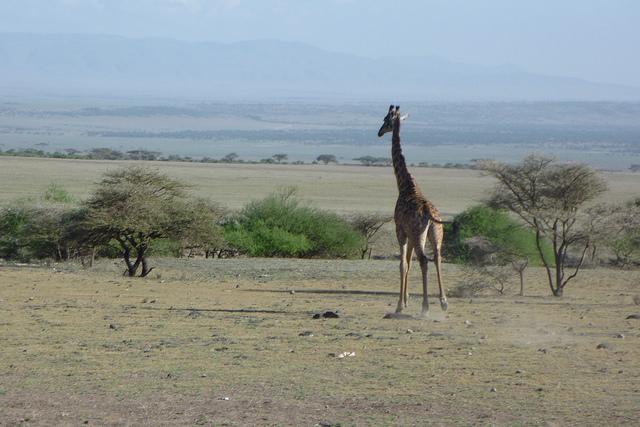How many giraffes are in the picture?
Keep it brief. 1. Where is the giraffe?
Give a very brief answer. Savannah. Which animals are these?
Quick response, please. Giraffe. Is this a park?
Concise answer only. No. Is the animal in the zoo?
Keep it brief. No. What surface are they on?
Short answer required. Dirt. What kind of animal is pictured here?
Keep it brief. Giraffe. 